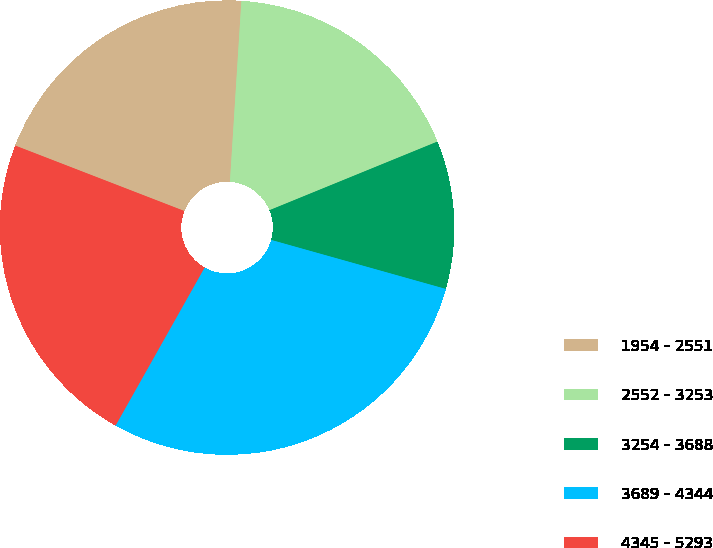Convert chart. <chart><loc_0><loc_0><loc_500><loc_500><pie_chart><fcel>1954 - 2551<fcel>2552 - 3253<fcel>3254 - 3688<fcel>3689 - 4344<fcel>4345 - 5293<nl><fcel>20.13%<fcel>17.82%<fcel>10.53%<fcel>28.81%<fcel>22.71%<nl></chart> 